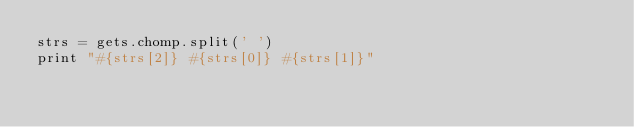Convert code to text. <code><loc_0><loc_0><loc_500><loc_500><_Ruby_>strs = gets.chomp.split(' ')
print "#{strs[2]} #{strs[0]} #{strs[1]}"</code> 